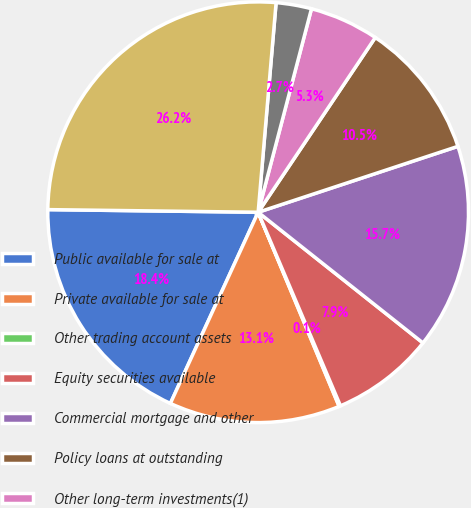<chart> <loc_0><loc_0><loc_500><loc_500><pie_chart><fcel>Public available for sale at<fcel>Private available for sale at<fcel>Other trading account assets<fcel>Equity securities available<fcel>Commercial mortgage and other<fcel>Policy loans at outstanding<fcel>Other long-term investments(1)<fcel>Short-term investments(2)<fcel>Total general account<nl><fcel>18.35%<fcel>13.14%<fcel>0.11%<fcel>7.93%<fcel>15.74%<fcel>10.53%<fcel>5.32%<fcel>2.72%<fcel>26.16%<nl></chart> 